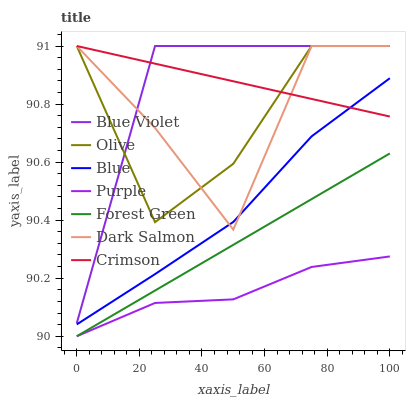Does Purple have the minimum area under the curve?
Answer yes or no. Yes. Does Blue Violet have the maximum area under the curve?
Answer yes or no. Yes. Does Dark Salmon have the minimum area under the curve?
Answer yes or no. No. Does Dark Salmon have the maximum area under the curve?
Answer yes or no. No. Is Crimson the smoothest?
Answer yes or no. Yes. Is Dark Salmon the roughest?
Answer yes or no. Yes. Is Purple the smoothest?
Answer yes or no. No. Is Purple the roughest?
Answer yes or no. No. Does Purple have the lowest value?
Answer yes or no. Yes. Does Dark Salmon have the lowest value?
Answer yes or no. No. Does Blue Violet have the highest value?
Answer yes or no. Yes. Does Purple have the highest value?
Answer yes or no. No. Is Purple less than Crimson?
Answer yes or no. Yes. Is Blue Violet greater than Forest Green?
Answer yes or no. Yes. Does Crimson intersect Olive?
Answer yes or no. Yes. Is Crimson less than Olive?
Answer yes or no. No. Is Crimson greater than Olive?
Answer yes or no. No. Does Purple intersect Crimson?
Answer yes or no. No. 